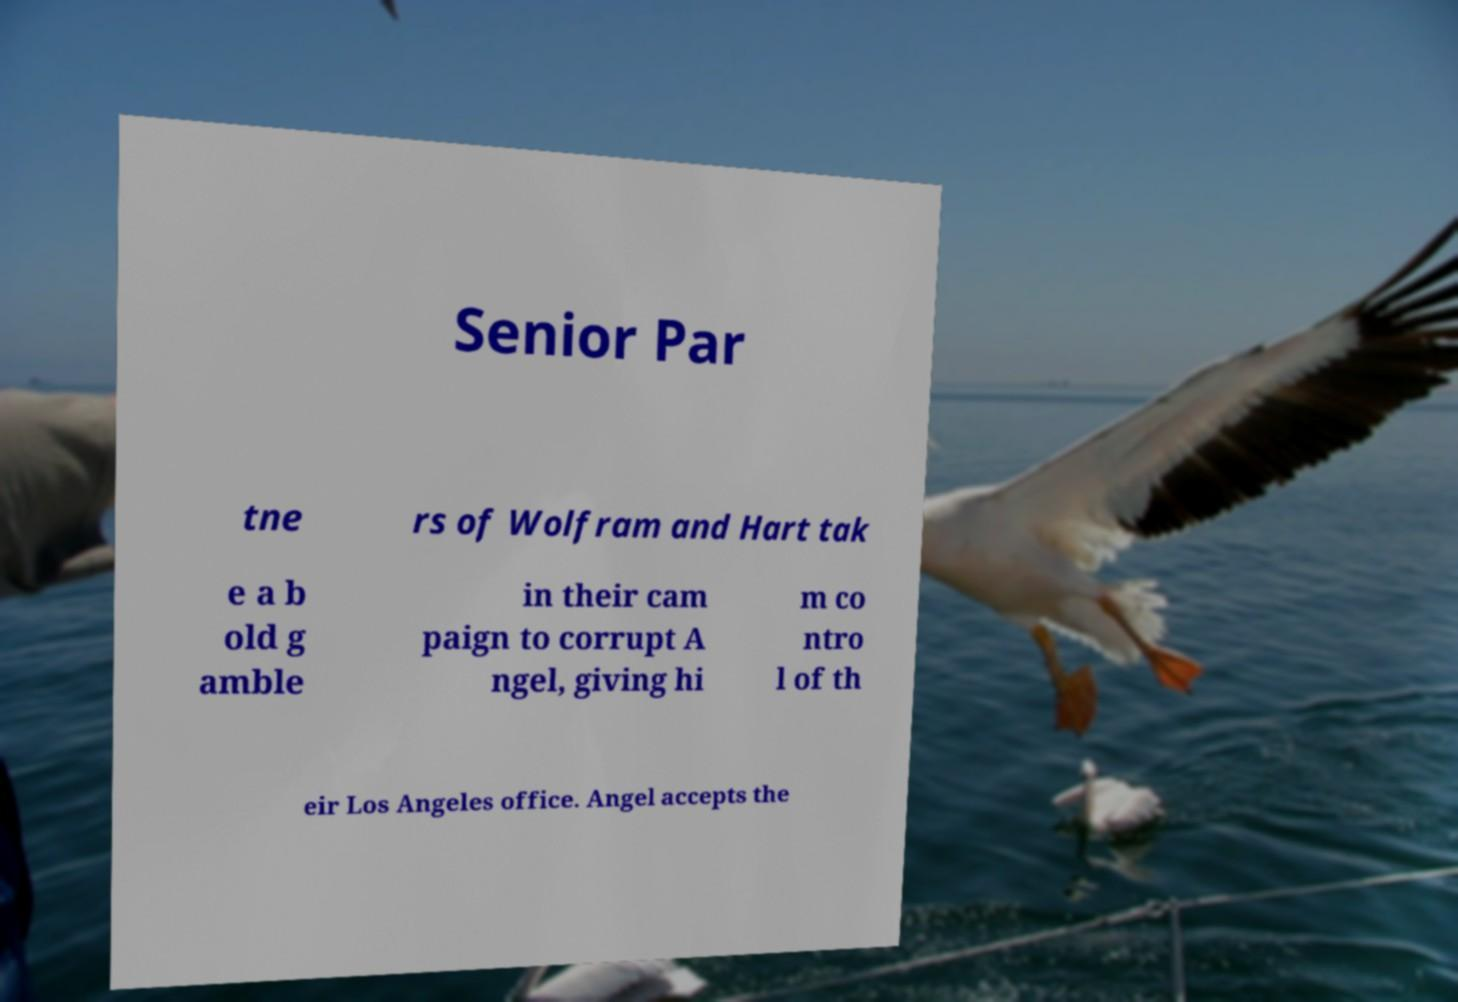Can you read and provide the text displayed in the image?This photo seems to have some interesting text. Can you extract and type it out for me? Senior Par tne rs of Wolfram and Hart tak e a b old g amble in their cam paign to corrupt A ngel, giving hi m co ntro l of th eir Los Angeles office. Angel accepts the 